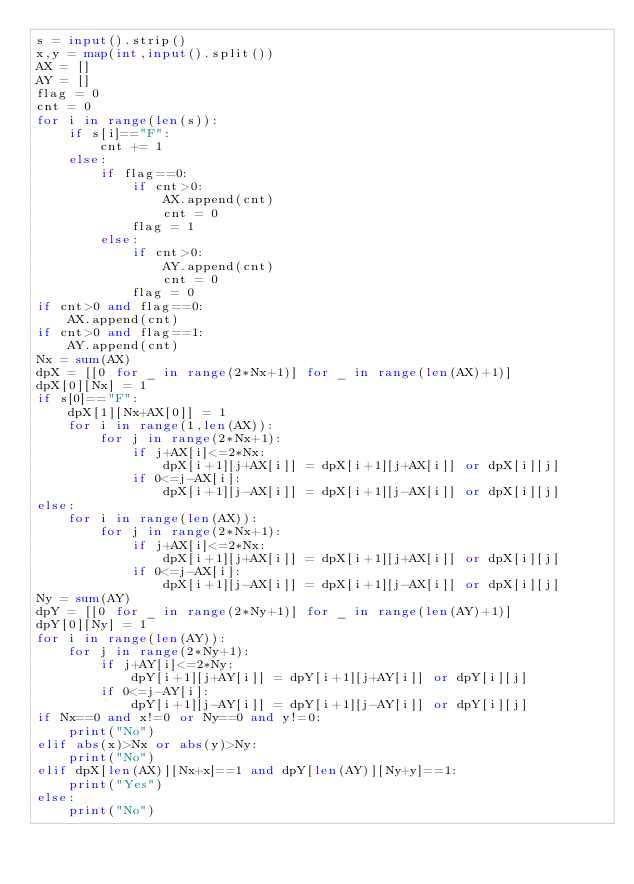<code> <loc_0><loc_0><loc_500><loc_500><_Python_>s = input().strip()
x,y = map(int,input().split())
AX = []
AY = []
flag = 0
cnt = 0
for i in range(len(s)):
    if s[i]=="F":
        cnt += 1
    else:
        if flag==0:
            if cnt>0:
                AX.append(cnt)
                cnt = 0
            flag = 1
        else:
            if cnt>0:
                AY.append(cnt)
                cnt = 0
            flag = 0
if cnt>0 and flag==0:
    AX.append(cnt)
if cnt>0 and flag==1:
    AY.append(cnt)
Nx = sum(AX)
dpX = [[0 for _ in range(2*Nx+1)] for _ in range(len(AX)+1)]
dpX[0][Nx] = 1
if s[0]=="F":
    dpX[1][Nx+AX[0]] = 1
    for i in range(1,len(AX)):
        for j in range(2*Nx+1):
            if j+AX[i]<=2*Nx:
                dpX[i+1][j+AX[i]] = dpX[i+1][j+AX[i]] or dpX[i][j]
            if 0<=j-AX[i]:
                dpX[i+1][j-AX[i]] = dpX[i+1][j-AX[i]] or dpX[i][j]
else:
    for i in range(len(AX)):
        for j in range(2*Nx+1):
            if j+AX[i]<=2*Nx:
                dpX[i+1][j+AX[i]] = dpX[i+1][j+AX[i]] or dpX[i][j]
            if 0<=j-AX[i]:
                dpX[i+1][j-AX[i]] = dpX[i+1][j-AX[i]] or dpX[i][j]
Ny = sum(AY)
dpY = [[0 for _ in range(2*Ny+1)] for _ in range(len(AY)+1)]
dpY[0][Ny] = 1
for i in range(len(AY)):
    for j in range(2*Ny+1):
        if j+AY[i]<=2*Ny:
            dpY[i+1][j+AY[i]] = dpY[i+1][j+AY[i]] or dpY[i][j]
        if 0<=j-AY[i]:
            dpY[i+1][j-AY[i]] = dpY[i+1][j-AY[i]] or dpY[i][j]
if Nx==0 and x!=0 or Ny==0 and y!=0:
    print("No")
elif abs(x)>Nx or abs(y)>Ny:
    print("No")
elif dpX[len(AX)][Nx+x]==1 and dpY[len(AY)][Ny+y]==1:
    print("Yes")
else:
    print("No")</code> 